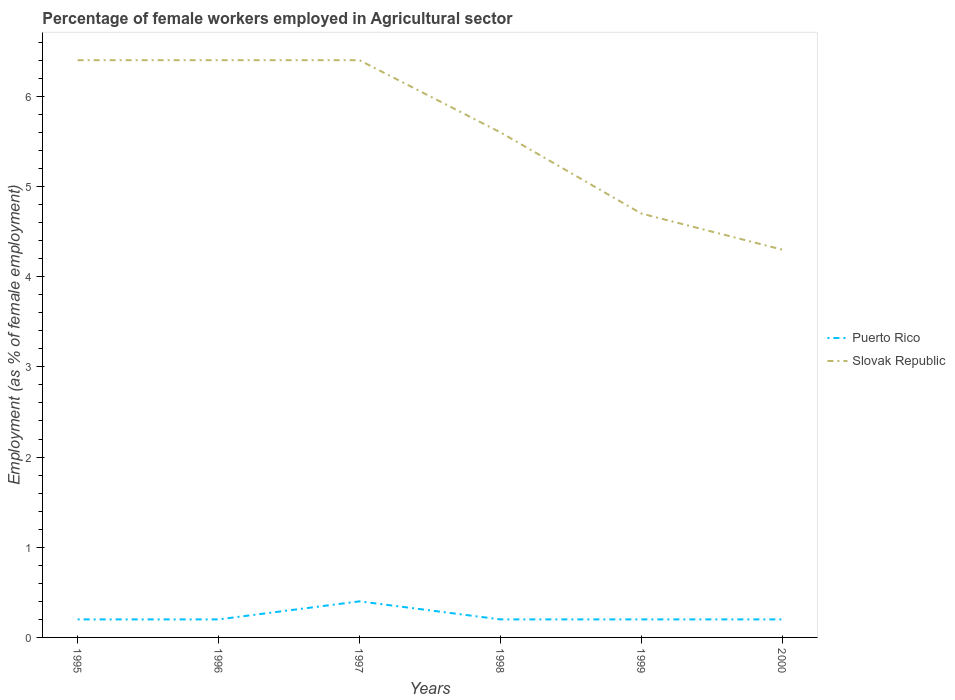Does the line corresponding to Puerto Rico intersect with the line corresponding to Slovak Republic?
Your answer should be compact. No. Across all years, what is the maximum percentage of females employed in Agricultural sector in Puerto Rico?
Make the answer very short. 0.2. What is the total percentage of females employed in Agricultural sector in Slovak Republic in the graph?
Provide a short and direct response. 2.1. What is the difference between the highest and the second highest percentage of females employed in Agricultural sector in Slovak Republic?
Make the answer very short. 2.1. What is the difference between the highest and the lowest percentage of females employed in Agricultural sector in Slovak Republic?
Make the answer very short. 3. Is the percentage of females employed in Agricultural sector in Slovak Republic strictly greater than the percentage of females employed in Agricultural sector in Puerto Rico over the years?
Give a very brief answer. No. How many lines are there?
Offer a very short reply. 2. What is the difference between two consecutive major ticks on the Y-axis?
Your answer should be very brief. 1. Are the values on the major ticks of Y-axis written in scientific E-notation?
Your answer should be compact. No. Does the graph contain grids?
Keep it short and to the point. No. How are the legend labels stacked?
Make the answer very short. Vertical. What is the title of the graph?
Your answer should be compact. Percentage of female workers employed in Agricultural sector. Does "Europe(all income levels)" appear as one of the legend labels in the graph?
Make the answer very short. No. What is the label or title of the X-axis?
Give a very brief answer. Years. What is the label or title of the Y-axis?
Offer a very short reply. Employment (as % of female employment). What is the Employment (as % of female employment) in Puerto Rico in 1995?
Keep it short and to the point. 0.2. What is the Employment (as % of female employment) in Slovak Republic in 1995?
Make the answer very short. 6.4. What is the Employment (as % of female employment) of Puerto Rico in 1996?
Offer a terse response. 0.2. What is the Employment (as % of female employment) in Slovak Republic in 1996?
Ensure brevity in your answer.  6.4. What is the Employment (as % of female employment) in Puerto Rico in 1997?
Offer a very short reply. 0.4. What is the Employment (as % of female employment) of Slovak Republic in 1997?
Your answer should be compact. 6.4. What is the Employment (as % of female employment) in Puerto Rico in 1998?
Your answer should be compact. 0.2. What is the Employment (as % of female employment) of Slovak Republic in 1998?
Your answer should be very brief. 5.6. What is the Employment (as % of female employment) in Puerto Rico in 1999?
Provide a short and direct response. 0.2. What is the Employment (as % of female employment) in Slovak Republic in 1999?
Ensure brevity in your answer.  4.7. What is the Employment (as % of female employment) of Puerto Rico in 2000?
Offer a very short reply. 0.2. What is the Employment (as % of female employment) in Slovak Republic in 2000?
Keep it short and to the point. 4.3. Across all years, what is the maximum Employment (as % of female employment) in Puerto Rico?
Give a very brief answer. 0.4. Across all years, what is the maximum Employment (as % of female employment) in Slovak Republic?
Keep it short and to the point. 6.4. Across all years, what is the minimum Employment (as % of female employment) of Puerto Rico?
Provide a succinct answer. 0.2. Across all years, what is the minimum Employment (as % of female employment) in Slovak Republic?
Provide a succinct answer. 4.3. What is the total Employment (as % of female employment) of Puerto Rico in the graph?
Keep it short and to the point. 1.4. What is the total Employment (as % of female employment) in Slovak Republic in the graph?
Your response must be concise. 33.8. What is the difference between the Employment (as % of female employment) of Puerto Rico in 1995 and that in 1996?
Keep it short and to the point. 0. What is the difference between the Employment (as % of female employment) of Slovak Republic in 1995 and that in 1997?
Your answer should be very brief. 0. What is the difference between the Employment (as % of female employment) of Puerto Rico in 1995 and that in 1999?
Give a very brief answer. 0. What is the difference between the Employment (as % of female employment) of Slovak Republic in 1995 and that in 1999?
Ensure brevity in your answer.  1.7. What is the difference between the Employment (as % of female employment) in Slovak Republic in 1996 and that in 1997?
Your answer should be very brief. 0. What is the difference between the Employment (as % of female employment) of Slovak Republic in 1996 and that in 1998?
Offer a terse response. 0.8. What is the difference between the Employment (as % of female employment) in Puerto Rico in 1996 and that in 2000?
Give a very brief answer. 0. What is the difference between the Employment (as % of female employment) in Puerto Rico in 1997 and that in 1999?
Provide a succinct answer. 0.2. What is the difference between the Employment (as % of female employment) in Slovak Republic in 1997 and that in 1999?
Your answer should be compact. 1.7. What is the difference between the Employment (as % of female employment) of Puerto Rico in 1997 and that in 2000?
Give a very brief answer. 0.2. What is the difference between the Employment (as % of female employment) of Puerto Rico in 1998 and that in 1999?
Offer a very short reply. 0. What is the difference between the Employment (as % of female employment) in Slovak Republic in 1998 and that in 1999?
Provide a succinct answer. 0.9. What is the difference between the Employment (as % of female employment) of Puerto Rico in 1998 and that in 2000?
Your response must be concise. 0. What is the difference between the Employment (as % of female employment) in Slovak Republic in 1998 and that in 2000?
Keep it short and to the point. 1.3. What is the difference between the Employment (as % of female employment) in Slovak Republic in 1999 and that in 2000?
Your answer should be compact. 0.4. What is the difference between the Employment (as % of female employment) in Puerto Rico in 1995 and the Employment (as % of female employment) in Slovak Republic in 1996?
Make the answer very short. -6.2. What is the difference between the Employment (as % of female employment) of Puerto Rico in 1995 and the Employment (as % of female employment) of Slovak Republic in 1999?
Ensure brevity in your answer.  -4.5. What is the difference between the Employment (as % of female employment) in Puerto Rico in 1995 and the Employment (as % of female employment) in Slovak Republic in 2000?
Your answer should be compact. -4.1. What is the difference between the Employment (as % of female employment) in Puerto Rico in 1996 and the Employment (as % of female employment) in Slovak Republic in 1998?
Keep it short and to the point. -5.4. What is the difference between the Employment (as % of female employment) of Puerto Rico in 1996 and the Employment (as % of female employment) of Slovak Republic in 1999?
Your answer should be very brief. -4.5. What is the difference between the Employment (as % of female employment) of Puerto Rico in 1996 and the Employment (as % of female employment) of Slovak Republic in 2000?
Provide a short and direct response. -4.1. What is the difference between the Employment (as % of female employment) in Puerto Rico in 1997 and the Employment (as % of female employment) in Slovak Republic in 1998?
Your response must be concise. -5.2. What is the difference between the Employment (as % of female employment) in Puerto Rico in 1997 and the Employment (as % of female employment) in Slovak Republic in 2000?
Ensure brevity in your answer.  -3.9. What is the difference between the Employment (as % of female employment) of Puerto Rico in 1998 and the Employment (as % of female employment) of Slovak Republic in 2000?
Provide a succinct answer. -4.1. What is the average Employment (as % of female employment) in Puerto Rico per year?
Offer a very short reply. 0.23. What is the average Employment (as % of female employment) in Slovak Republic per year?
Offer a very short reply. 5.63. In the year 1997, what is the difference between the Employment (as % of female employment) of Puerto Rico and Employment (as % of female employment) of Slovak Republic?
Your answer should be very brief. -6. In the year 1998, what is the difference between the Employment (as % of female employment) of Puerto Rico and Employment (as % of female employment) of Slovak Republic?
Provide a short and direct response. -5.4. What is the ratio of the Employment (as % of female employment) in Puerto Rico in 1995 to that in 1996?
Keep it short and to the point. 1. What is the ratio of the Employment (as % of female employment) in Slovak Republic in 1995 to that in 1997?
Offer a terse response. 1. What is the ratio of the Employment (as % of female employment) of Puerto Rico in 1995 to that in 1998?
Provide a short and direct response. 1. What is the ratio of the Employment (as % of female employment) in Slovak Republic in 1995 to that in 1998?
Offer a very short reply. 1.14. What is the ratio of the Employment (as % of female employment) in Puerto Rico in 1995 to that in 1999?
Make the answer very short. 1. What is the ratio of the Employment (as % of female employment) in Slovak Republic in 1995 to that in 1999?
Provide a short and direct response. 1.36. What is the ratio of the Employment (as % of female employment) in Puerto Rico in 1995 to that in 2000?
Your answer should be very brief. 1. What is the ratio of the Employment (as % of female employment) of Slovak Republic in 1995 to that in 2000?
Your answer should be very brief. 1.49. What is the ratio of the Employment (as % of female employment) of Puerto Rico in 1996 to that in 1998?
Your response must be concise. 1. What is the ratio of the Employment (as % of female employment) in Slovak Republic in 1996 to that in 1998?
Keep it short and to the point. 1.14. What is the ratio of the Employment (as % of female employment) in Puerto Rico in 1996 to that in 1999?
Give a very brief answer. 1. What is the ratio of the Employment (as % of female employment) in Slovak Republic in 1996 to that in 1999?
Provide a succinct answer. 1.36. What is the ratio of the Employment (as % of female employment) in Slovak Republic in 1996 to that in 2000?
Offer a terse response. 1.49. What is the ratio of the Employment (as % of female employment) of Puerto Rico in 1997 to that in 1998?
Make the answer very short. 2. What is the ratio of the Employment (as % of female employment) in Slovak Republic in 1997 to that in 1999?
Give a very brief answer. 1.36. What is the ratio of the Employment (as % of female employment) in Slovak Republic in 1997 to that in 2000?
Provide a succinct answer. 1.49. What is the ratio of the Employment (as % of female employment) of Slovak Republic in 1998 to that in 1999?
Offer a terse response. 1.19. What is the ratio of the Employment (as % of female employment) in Puerto Rico in 1998 to that in 2000?
Make the answer very short. 1. What is the ratio of the Employment (as % of female employment) in Slovak Republic in 1998 to that in 2000?
Your answer should be very brief. 1.3. What is the ratio of the Employment (as % of female employment) of Puerto Rico in 1999 to that in 2000?
Offer a very short reply. 1. What is the ratio of the Employment (as % of female employment) of Slovak Republic in 1999 to that in 2000?
Offer a very short reply. 1.09. What is the difference between the highest and the lowest Employment (as % of female employment) in Slovak Republic?
Your answer should be compact. 2.1. 